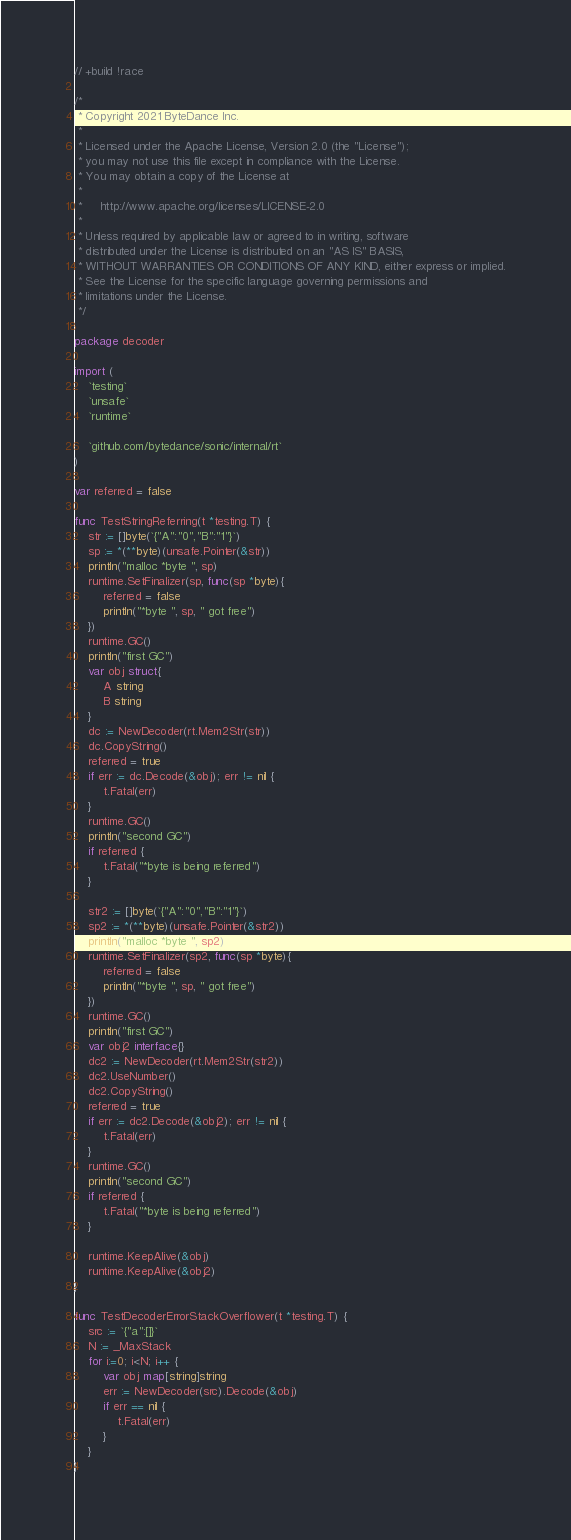<code> <loc_0><loc_0><loc_500><loc_500><_Go_>// +build !race

/*
 * Copyright 2021 ByteDance Inc.
 *
 * Licensed under the Apache License, Version 2.0 (the "License");
 * you may not use this file except in compliance with the License.
 * You may obtain a copy of the License at
 *
 *     http://www.apache.org/licenses/LICENSE-2.0
 *
 * Unless required by applicable law or agreed to in writing, software
 * distributed under the License is distributed on an "AS IS" BASIS,
 * WITHOUT WARRANTIES OR CONDITIONS OF ANY KIND, either express or implied.
 * See the License for the specific language governing permissions and
 * limitations under the License.
 */

package decoder

import (
	`testing`
	`unsafe`
	`runtime`

	`github.com/bytedance/sonic/internal/rt`
)

var referred = false

func TestStringReferring(t *testing.T) {
    str := []byte(`{"A":"0","B":"1"}`)
    sp := *(**byte)(unsafe.Pointer(&str))
    println("malloc *byte ", sp)
    runtime.SetFinalizer(sp, func(sp *byte){
        referred = false
        println("*byte ", sp, " got free")
    })
    runtime.GC()
    println("first GC")
    var obj struct{
        A string
        B string
    }
    dc := NewDecoder(rt.Mem2Str(str))
    dc.CopyString()
    referred = true
    if err := dc.Decode(&obj); err != nil {
        t.Fatal(err)
    }
    runtime.GC()
    println("second GC")
    if referred {
        t.Fatal("*byte is being referred")
    }

    str2 := []byte(`{"A":"0","B":"1"}`)
    sp2 := *(**byte)(unsafe.Pointer(&str2))
    println("malloc *byte ", sp2)
    runtime.SetFinalizer(sp2, func(sp *byte){
        referred = false
        println("*byte ", sp, " got free")
    })
    runtime.GC()
    println("first GC")
    var obj2 interface{}
    dc2 := NewDecoder(rt.Mem2Str(str2))
    dc2.UseNumber()
    dc2.CopyString()
    referred = true
    if err := dc2.Decode(&obj2); err != nil {
        t.Fatal(err)
    }
    runtime.GC()
    println("second GC")
    if referred {
        t.Fatal("*byte is being referred")
    }
    
    runtime.KeepAlive(&obj)
    runtime.KeepAlive(&obj2)
}

func TestDecoderErrorStackOverflower(t *testing.T) {
    src := `{"a":[]}`
    N := _MaxStack
    for i:=0; i<N; i++ {
        var obj map[string]string
        err := NewDecoder(src).Decode(&obj)
        if err == nil {
            t.Fatal(err)
        }
    }
}</code> 